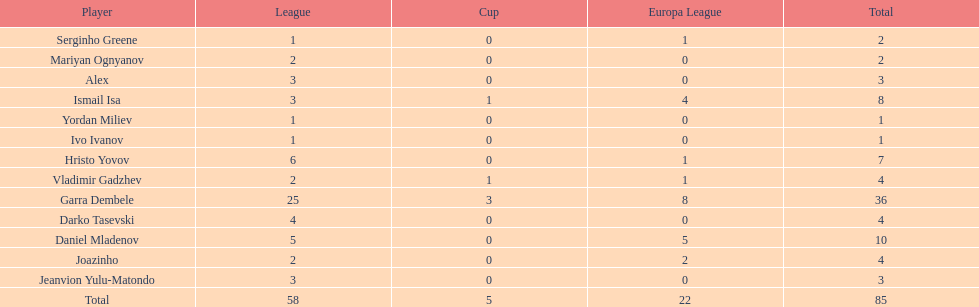Which total is higher, the europa league total or the league total? League. 